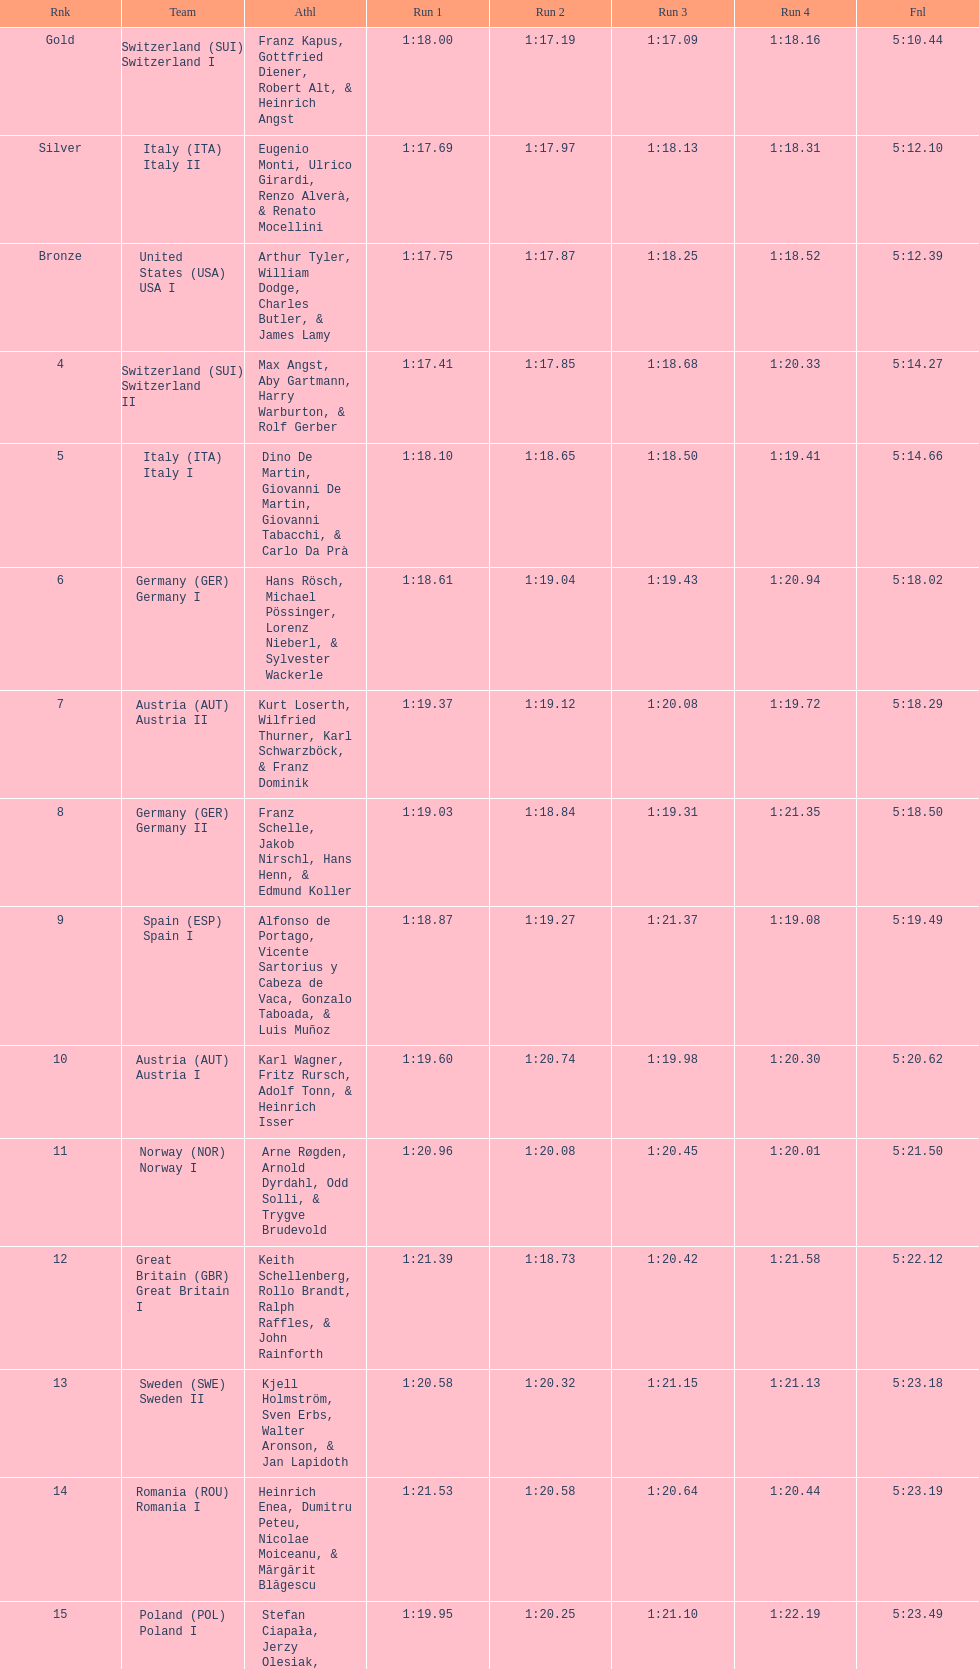What is the total amount of runs? 4. 